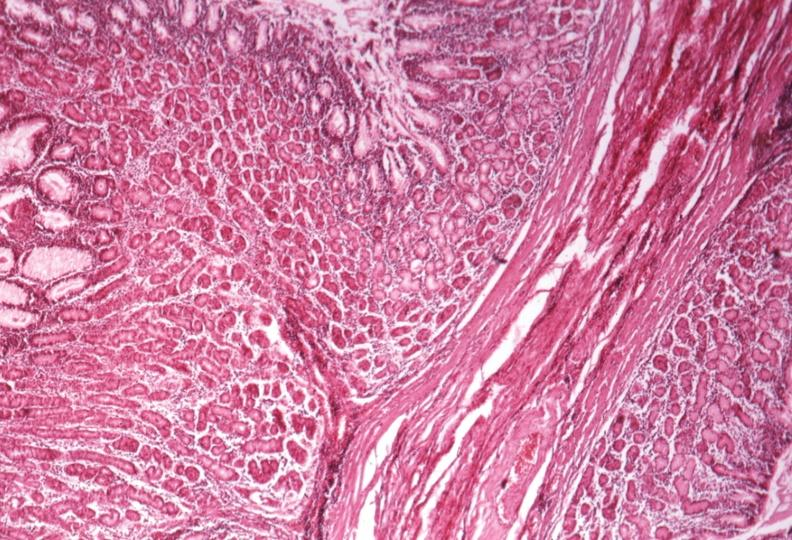what is present?
Answer the question using a single word or phrase. Gastrointestinal 